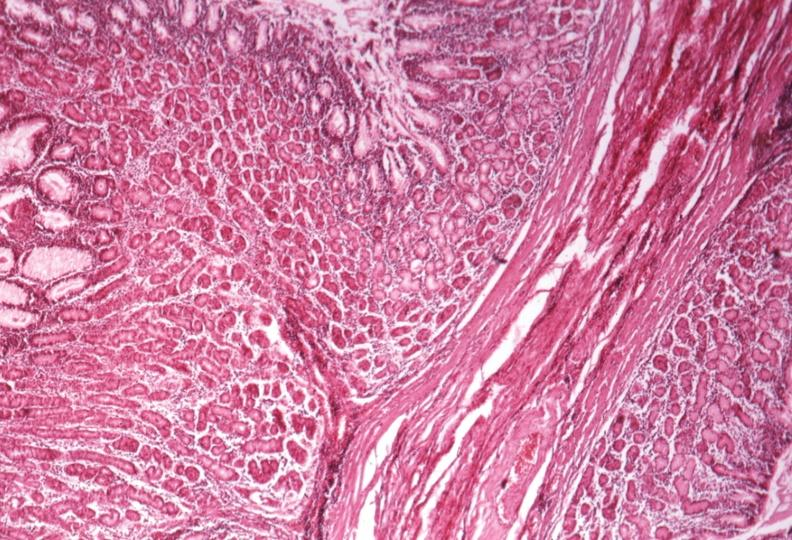what is present?
Answer the question using a single word or phrase. Gastrointestinal 